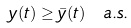Convert formula to latex. <formula><loc_0><loc_0><loc_500><loc_500>y ( t ) \geq \bar { y } ( t ) \ a . s .</formula> 